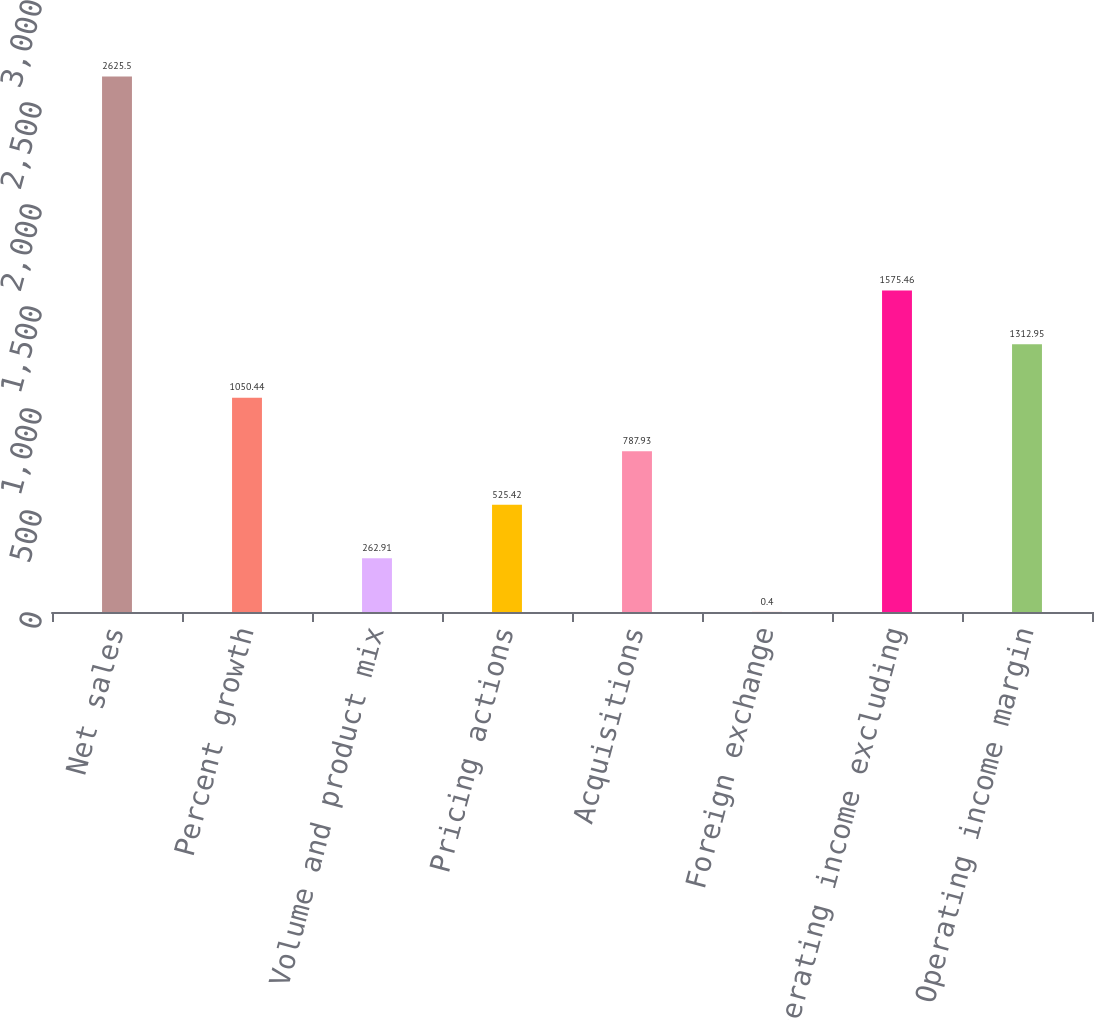Convert chart. <chart><loc_0><loc_0><loc_500><loc_500><bar_chart><fcel>Net sales<fcel>Percent growth<fcel>Volume and product mix<fcel>Pricing actions<fcel>Acquisitions<fcel>Foreign exchange<fcel>Operating income excluding<fcel>Operating income margin<nl><fcel>2625.5<fcel>1050.44<fcel>262.91<fcel>525.42<fcel>787.93<fcel>0.4<fcel>1575.46<fcel>1312.95<nl></chart> 